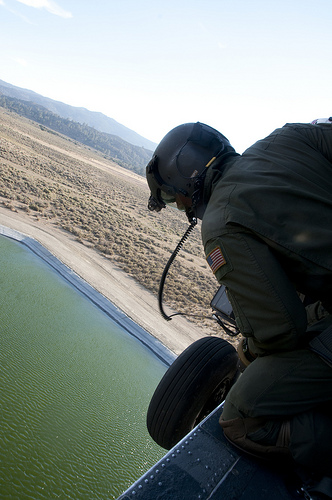<image>
Is there a water under the man? Yes. The water is positioned underneath the man, with the man above it in the vertical space. 